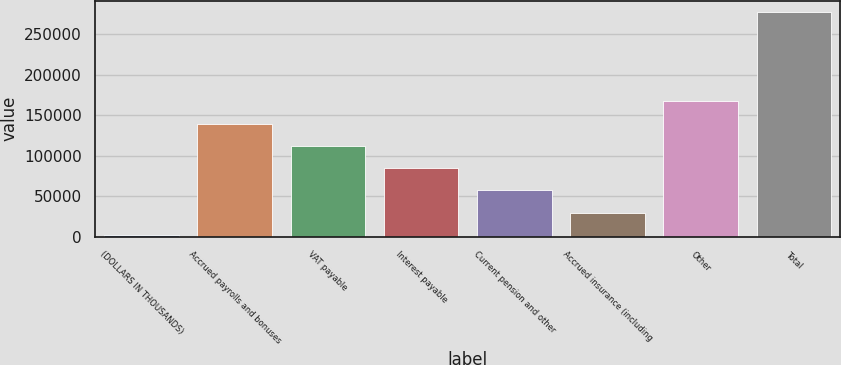<chart> <loc_0><loc_0><loc_500><loc_500><bar_chart><fcel>(DOLLARS IN THOUSANDS)<fcel>Accrued payrolls and bonuses<fcel>VAT payable<fcel>Interest payable<fcel>Current pension and other<fcel>Accrued insurance (including<fcel>Other<fcel>Total<nl><fcel>2012<fcel>139699<fcel>112162<fcel>84624.2<fcel>57086.8<fcel>29549.4<fcel>167236<fcel>277386<nl></chart> 